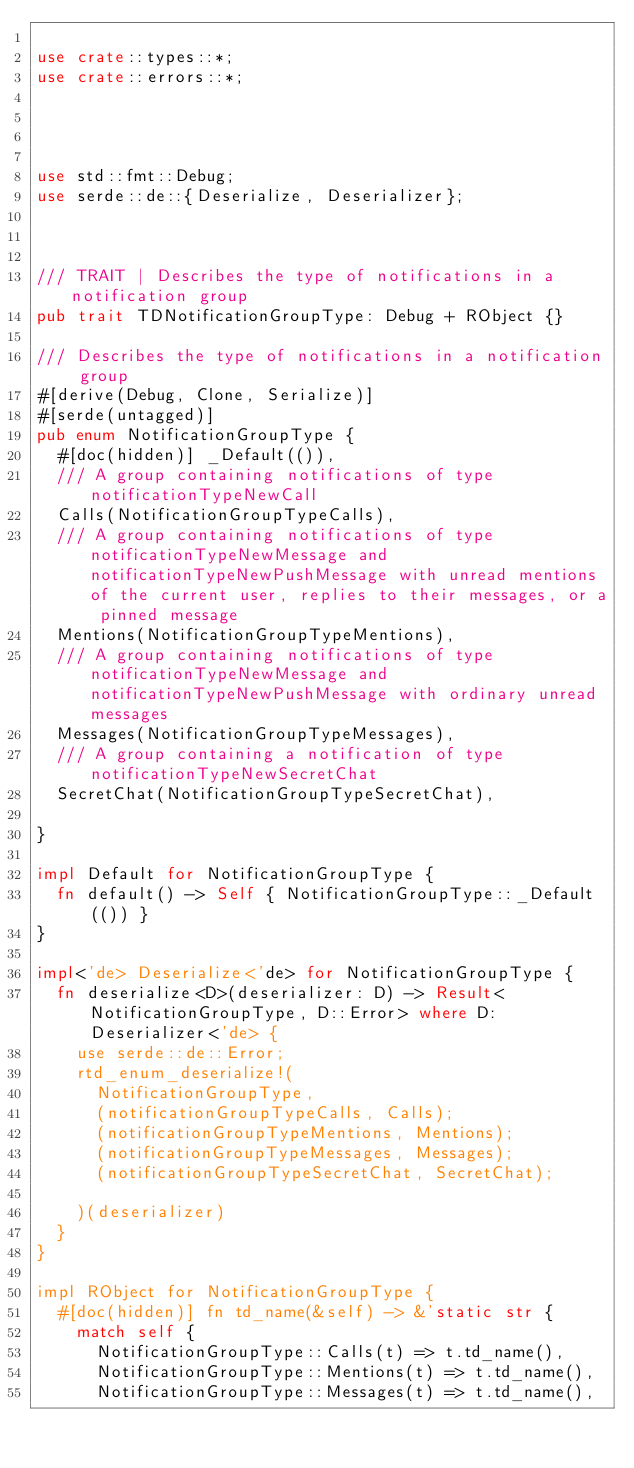<code> <loc_0><loc_0><loc_500><loc_500><_Rust_>
use crate::types::*;
use crate::errors::*;




use std::fmt::Debug;
use serde::de::{Deserialize, Deserializer};



/// TRAIT | Describes the type of notifications in a notification group
pub trait TDNotificationGroupType: Debug + RObject {}

/// Describes the type of notifications in a notification group
#[derive(Debug, Clone, Serialize)]
#[serde(untagged)]
pub enum NotificationGroupType {
  #[doc(hidden)] _Default(()),
  /// A group containing notifications of type notificationTypeNewCall
  Calls(NotificationGroupTypeCalls),
  /// A group containing notifications of type notificationTypeNewMessage and notificationTypeNewPushMessage with unread mentions of the current user, replies to their messages, or a pinned message
  Mentions(NotificationGroupTypeMentions),
  /// A group containing notifications of type notificationTypeNewMessage and notificationTypeNewPushMessage with ordinary unread messages
  Messages(NotificationGroupTypeMessages),
  /// A group containing a notification of type notificationTypeNewSecretChat
  SecretChat(NotificationGroupTypeSecretChat),

}

impl Default for NotificationGroupType {
  fn default() -> Self { NotificationGroupType::_Default(()) }
}

impl<'de> Deserialize<'de> for NotificationGroupType {
  fn deserialize<D>(deserializer: D) -> Result<NotificationGroupType, D::Error> where D: Deserializer<'de> {
    use serde::de::Error;
    rtd_enum_deserialize!(
      NotificationGroupType,
      (notificationGroupTypeCalls, Calls);
      (notificationGroupTypeMentions, Mentions);
      (notificationGroupTypeMessages, Messages);
      (notificationGroupTypeSecretChat, SecretChat);

    )(deserializer)
  }
}

impl RObject for NotificationGroupType {
  #[doc(hidden)] fn td_name(&self) -> &'static str {
    match self {
      NotificationGroupType::Calls(t) => t.td_name(),
      NotificationGroupType::Mentions(t) => t.td_name(),
      NotificationGroupType::Messages(t) => t.td_name(),</code> 